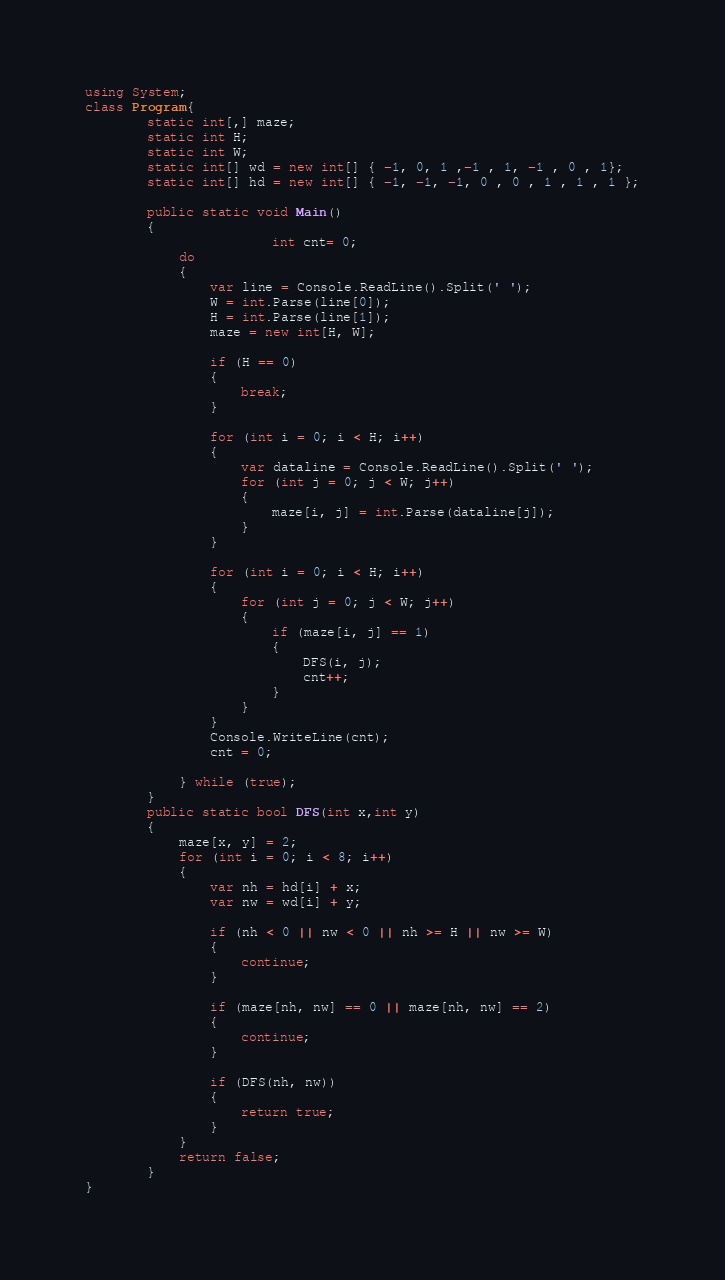<code> <loc_0><loc_0><loc_500><loc_500><_C#_>using System;
class Program{
        static int[,] maze;
        static int H;
        static int W;
        static int[] wd = new int[] { -1, 0, 1 ,-1 , 1, -1 , 0 , 1};
        static int[] hd = new int[] { -1, -1, -1, 0 , 0 , 1 , 1 , 1 };

        public static void Main()
        {
                        int cnt= 0;
            do
            {
                var line = Console.ReadLine().Split(' ');
                W = int.Parse(line[0]);
                H = int.Parse(line[1]);
                maze = new int[H, W];

                if (H == 0)
                {
                    break;
                }

                for (int i = 0; i < H; i++)
                {
                    var dataline = Console.ReadLine().Split(' ');
                    for (int j = 0; j < W; j++)
                    {
                        maze[i, j] = int.Parse(dataline[j]);
                    }
                }

                for (int i = 0; i < H; i++)
                {
                    for (int j = 0; j < W; j++)
                    {
                        if (maze[i, j] == 1)
                        {
                            DFS(i, j);
                            cnt++;
                        }
                    }
                }
                Console.WriteLine(cnt);
                cnt = 0;

            } while (true);
        }
        public static bool DFS(int x,int y)
        {
            maze[x, y] = 2;
            for (int i = 0; i < 8; i++)
            {
                var nh = hd[i] + x;
                var nw = wd[i] + y;

                if (nh < 0 || nw < 0 || nh >= H || nw >= W)
                {
                    continue;
                }

                if (maze[nh, nw] == 0 || maze[nh, nw] == 2)
                {
                    continue;
                }

                if (DFS(nh, nw))
                {
                    return true;
                }
            }
            return false;
        }
}
</code> 